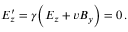<formula> <loc_0><loc_0><loc_500><loc_500>E _ { z } ^ { \prime } = \gamma \left ( E _ { z } + v B _ { y } \right ) = 0 \, .</formula> 